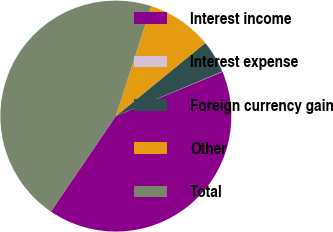Convert chart to OTSL. <chart><loc_0><loc_0><loc_500><loc_500><pie_chart><fcel>Interest income<fcel>Interest expense<fcel>Foreign currency gain<fcel>Other<fcel>Total<nl><fcel>40.79%<fcel>0.05%<fcel>4.59%<fcel>9.13%<fcel>45.45%<nl></chart> 